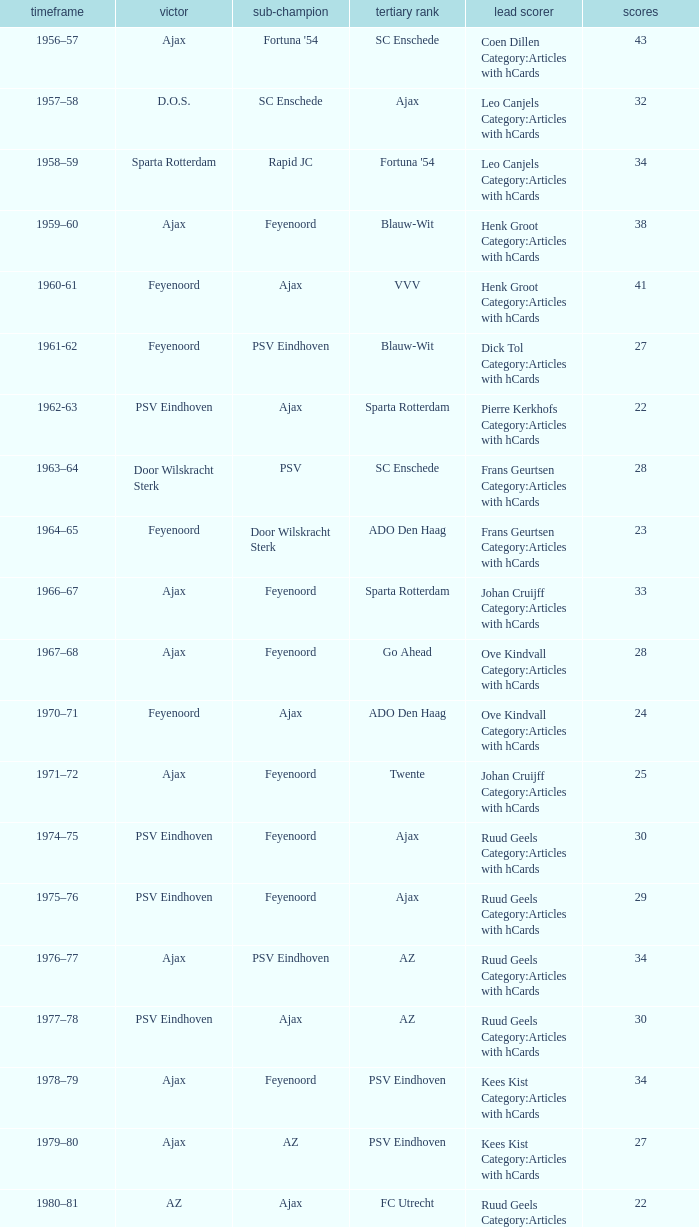Help me parse the entirety of this table. {'header': ['timeframe', 'victor', 'sub-champion', 'tertiary rank', 'lead scorer', 'scores'], 'rows': [['1956–57', 'Ajax', "Fortuna '54", 'SC Enschede', 'Coen Dillen Category:Articles with hCards', '43'], ['1957–58', 'D.O.S.', 'SC Enschede', 'Ajax', 'Leo Canjels Category:Articles with hCards', '32'], ['1958–59', 'Sparta Rotterdam', 'Rapid JC', "Fortuna '54", 'Leo Canjels Category:Articles with hCards', '34'], ['1959–60', 'Ajax', 'Feyenoord', 'Blauw-Wit', 'Henk Groot Category:Articles with hCards', '38'], ['1960-61', 'Feyenoord', 'Ajax', 'VVV', 'Henk Groot Category:Articles with hCards', '41'], ['1961-62', 'Feyenoord', 'PSV Eindhoven', 'Blauw-Wit', 'Dick Tol Category:Articles with hCards', '27'], ['1962-63', 'PSV Eindhoven', 'Ajax', 'Sparta Rotterdam', 'Pierre Kerkhofs Category:Articles with hCards', '22'], ['1963–64', 'Door Wilskracht Sterk', 'PSV', 'SC Enschede', 'Frans Geurtsen Category:Articles with hCards', '28'], ['1964–65', 'Feyenoord', 'Door Wilskracht Sterk', 'ADO Den Haag', 'Frans Geurtsen Category:Articles with hCards', '23'], ['1966–67', 'Ajax', 'Feyenoord', 'Sparta Rotterdam', 'Johan Cruijff Category:Articles with hCards', '33'], ['1967–68', 'Ajax', 'Feyenoord', 'Go Ahead', 'Ove Kindvall Category:Articles with hCards', '28'], ['1970–71', 'Feyenoord', 'Ajax', 'ADO Den Haag', 'Ove Kindvall Category:Articles with hCards', '24'], ['1971–72', 'Ajax', 'Feyenoord', 'Twente', 'Johan Cruijff Category:Articles with hCards', '25'], ['1974–75', 'PSV Eindhoven', 'Feyenoord', 'Ajax', 'Ruud Geels Category:Articles with hCards', '30'], ['1975–76', 'PSV Eindhoven', 'Feyenoord', 'Ajax', 'Ruud Geels Category:Articles with hCards', '29'], ['1976–77', 'Ajax', 'PSV Eindhoven', 'AZ', 'Ruud Geels Category:Articles with hCards', '34'], ['1977–78', 'PSV Eindhoven', 'Ajax', 'AZ', 'Ruud Geels Category:Articles with hCards', '30'], ['1978–79', 'Ajax', 'Feyenoord', 'PSV Eindhoven', 'Kees Kist Category:Articles with hCards', '34'], ['1979–80', 'Ajax', 'AZ', 'PSV Eindhoven', 'Kees Kist Category:Articles with hCards', '27'], ['1980–81', 'AZ', 'Ajax', 'FC Utrecht', 'Ruud Geels Category:Articles with hCards', '22'], ['1981-82', 'Ajax', 'PSV Eindhoven', 'AZ', 'Wim Kieft Category:Articles with hCards', '32'], ['1982-83', 'Ajax', 'Feyenoord', 'PSV Eindhoven', 'Peter Houtman Category:Articles with hCards', '30'], ['1983-84', 'Feyenoord', 'PSV Eindhoven', 'Ajax', 'Marco van Basten Category:Articles with hCards', '28'], ['1984-85', 'Ajax', 'PSV Eindhoven', 'Feyenoord', 'Marco van Basten Category:Articles with hCards', '22'], ['1985-86', 'PSV Eindhoven', 'Ajax', 'Feyenoord', 'Marco van Basten Category:Articles with hCards', '37'], ['1986-87', 'PSV Eindhoven', 'Ajax', 'Feyenoord', 'Marco van Basten Category:Articles with hCards', '31'], ['1987-88', 'PSV Eindhoven', 'Ajax', 'Twente', 'Wim Kieft Category:Articles with hCards', '29'], ['1988–89', 'PSV Eindhoven', 'Ajax', 'Twente', 'Romário', '19'], ['1989-90', 'Ajax', 'PSV Eindhoven', 'Twente', 'Romário', '23'], ['1990–91', 'PSV Eindhoven', 'Ajax', 'FC Groningen', 'Romário Dennis Bergkamp', '25'], ['1991–92', 'PSV Eindhoven', 'Ajax', 'Feyenoord', 'Dennis Bergkamp Category:Articles with hCards', '22'], ['1992–93', 'Feyenoord', 'PSV Eindhoven', 'Ajax', 'Dennis Bergkamp Category:Articles with hCards', '26'], ['1993–94', 'Ajax', 'Feyenoord', 'PSV Eindhoven', 'Jari Litmanen Category:Articles with hCards', '26'], ['1994–95', 'Ajax', 'Roda JC', 'PSV Eindhoven', 'Ronaldo', '30'], ['1995–96', 'Ajax', 'PSV Eindhoven', 'Feyenoord', 'Luc Nilis Category:Articles with hCards', '21'], ['1996–97', 'PSV Eindhoven', 'Feyenoord', 'Twente', 'Luc Nilis Category:Articles with hCards', '21'], ['1997–98', 'Ajax', 'PSV Eindhoven', 'Vitesse', 'Nikos Machlas Category:Articles with hCards', '34'], ['1998–99', 'Feyenoord', 'Willem II', 'PSV Eindhoven', 'Ruud van Nistelrooy Category:Articles with hCards', '31'], ['1999–2000', 'PSV Eindhoven', 'Heerenveen', 'Feyenoord', 'Ruud van Nistelrooy Category:Articles with hCards', '29'], ['2000–01', 'PSV Eindhoven', 'Feyenoord', 'Ajax', 'Mateja Kežman Category:Articles with hCards', '24'], ['2001–02', 'Ajax', 'PSV Eindhoven', 'Feyenoord', 'Pierre van Hooijdonk Category:Articles with hCards', '24'], ['2002-03', 'PSV Eindhoven', 'Ajax', 'Feyenoord', 'Mateja Kežman Category:Articles with hCards', '35'], ['2003-04', 'Ajax', 'PSV Eindhoven', 'Feyenoord', 'Mateja Kežman Category:Articles with hCards', '31'], ['2004-05', 'PSV Eindhoven', 'Ajax', 'AZ', 'Dirk Kuyt Category:Articles with hCards', '29'], ['2005-06', 'PSV Eindhoven', 'AZ', 'Feyenoord', 'Klaas-Jan Huntelaar Category:Articles with hCards', '33'], ['2006-07', 'PSV Eindhoven', 'Ajax', 'AZ', 'Afonso Alves Category:Articles with hCards', '34'], ['2007-08', 'PSV Eindhoven', 'Ajax', 'NAC Breda', 'Klaas-Jan Huntelaar Category:Articles with hCards', '33'], ['2008-09', 'AZ', 'Twente', 'Ajax', 'Mounir El Hamdaoui Category:Articles with hCards', '23'], ['2009-10', 'Twente', 'Ajax', 'PSV Eindhoven', 'Luis Suárez Category:Articles with hCards', '35'], ['2010-11', 'Ajax', 'Twente', 'PSV Eindhoven', 'Björn Vleminckx Category:Articles with hCards', '23'], ['2011-12', 'Ajax', 'Feyenoord', 'PSV Eindhoven', 'Bas Dost Category:Articles with hCards', '32']]} When nac breda came in third place and psv eindhoven was the winner who is the top scorer? Klaas-Jan Huntelaar Category:Articles with hCards. 